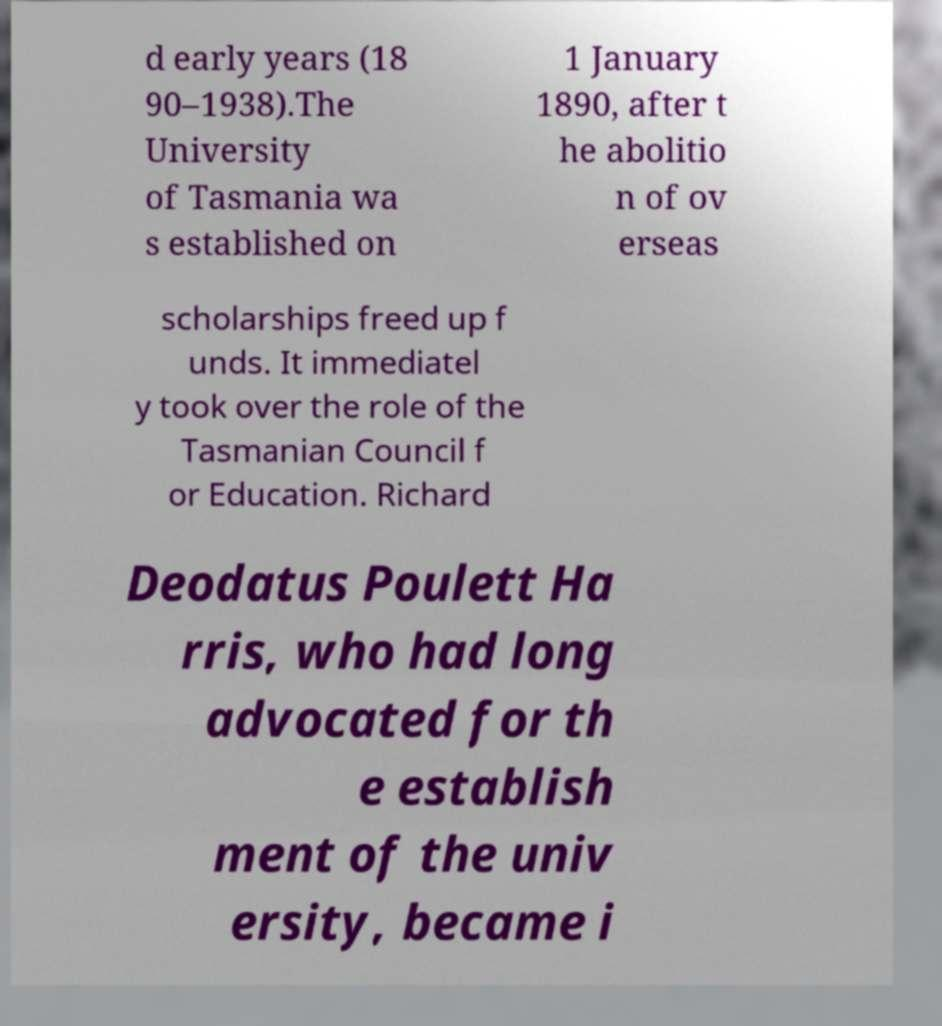Please identify and transcribe the text found in this image. d early years (18 90–1938).The University of Tasmania wa s established on 1 January 1890, after t he abolitio n of ov erseas scholarships freed up f unds. It immediatel y took over the role of the Tasmanian Council f or Education. Richard Deodatus Poulett Ha rris, who had long advocated for th e establish ment of the univ ersity, became i 